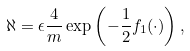Convert formula to latex. <formula><loc_0><loc_0><loc_500><loc_500>\aleph = \epsilon \frac { 4 } { m } \exp \left ( - \frac { 1 } { 2 } f _ { 1 } ( \cdot ) \right ) ,</formula> 